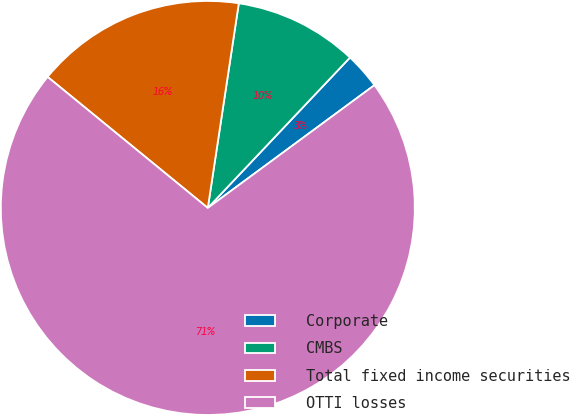Convert chart to OTSL. <chart><loc_0><loc_0><loc_500><loc_500><pie_chart><fcel>Corporate<fcel>CMBS<fcel>Total fixed income securities<fcel>OTTI losses<nl><fcel>2.84%<fcel>9.66%<fcel>16.48%<fcel>71.02%<nl></chart> 